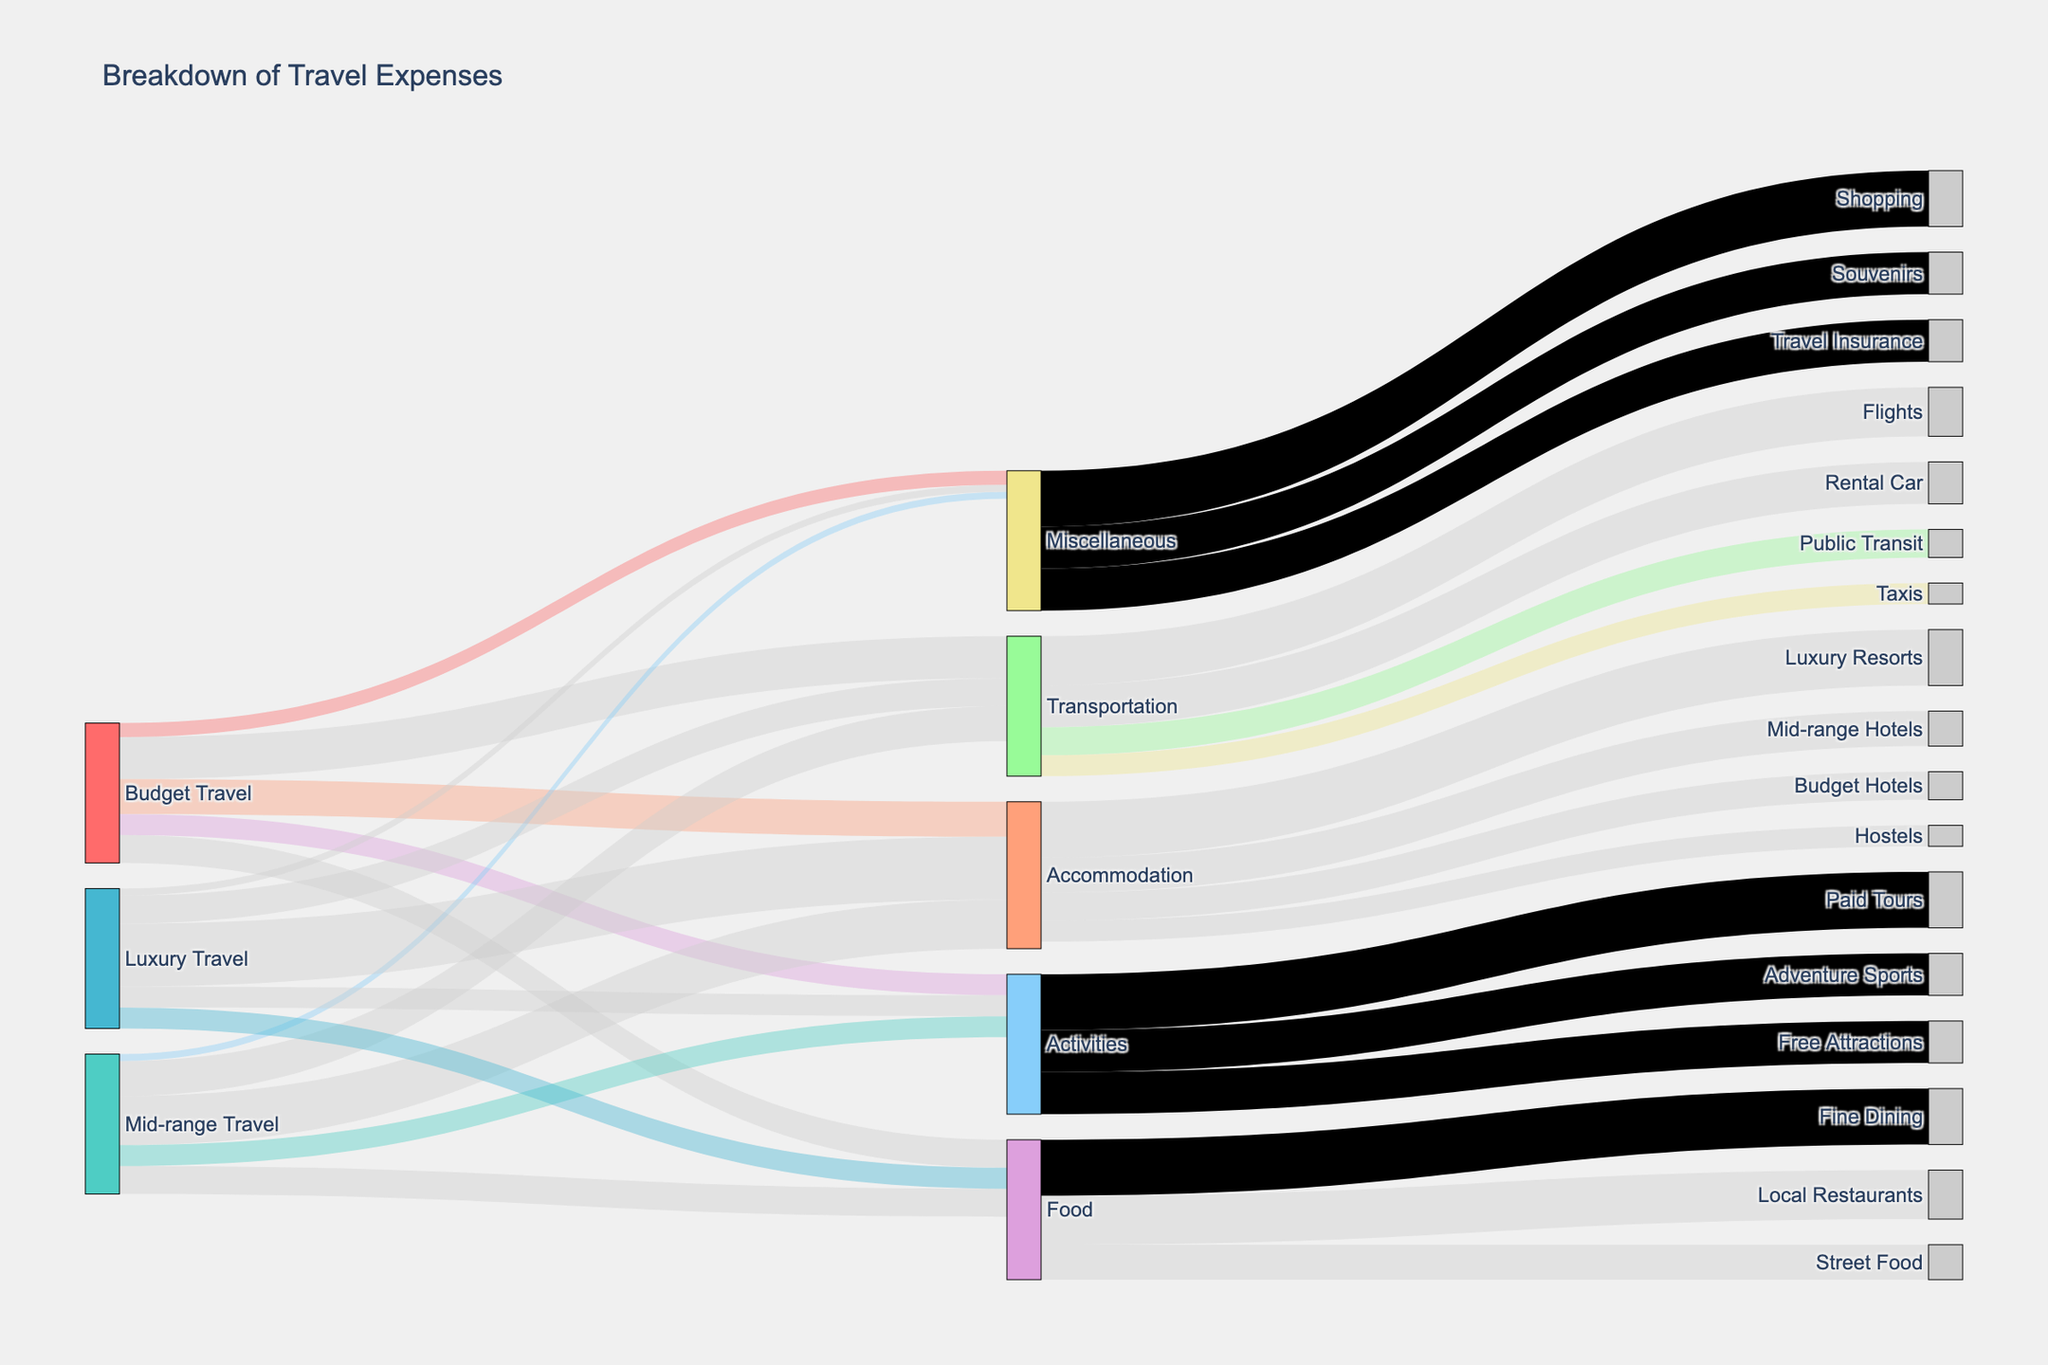What is the title of the figure? The title is located at the top center of the figure. It helps to identify the main subject of the diagram.
Answer: Breakdown of Travel Expenses Which travel type has the highest allocation for Accommodation? By tracing the length and thickness of the "Accommodation" flow from each travel type (Budget, Mid-range, Luxury), it is apparent that Luxury Travel has the thickest and longest line associated with Accommodation.
Answer: Luxury Travel What is the total value allocated to Food across all travel types? To find the total value, sum the values from Budget Travel, Mid-range Travel, and Luxury Travel directed towards Food. This means adding: Budget (20) + Mid-range (20) + Luxury (15).
Answer: 55 How much more does Luxury Travel spend on Accommodation compared to Budget Travel? Find the value of Accommodation for both Luxury (45) and Budget (25) from their corresponding flows, and then subtract Budget's value from Luxury's.
Answer: 20 Compare the overall transport expenditures between Budget Travel and Luxury Travel. Sum the value of each travel type's segments leading to Transportation: Budget (30) and Luxury (20), and compare the sums. Budget Travel spends more.
Answer: Budget Travel Which activity category receives the highest value allocation? Look at the flow lines leading to different activities and identify which has the thickest and longest line. "Paid Tours" receives the highest allocation (40).
Answer: Paid Tours What are the two most allocated categories in Budget Travel? From Budget Travel, observe the thickness and length of lines leading to their respective targets. Accommodation and Transportation have the highest values (25 and 30).
Answer: Transportation, Accommodation In Mid-range Travel, which category has the smallest allocation? Identify the flow lines from Mid-range Travel towards different categories and find the thinnest/smallest one. Miscellaneous has an allocation of only 5.
Answer: Miscellaneous How much does Mid-range Travel allocate more on Accommodation compared to Budget Travel? Identify Mid-range Accommodation (35) and Budget Accommodation (25). Subtract the Budget value from the Mid-range value.
Answer: 10 